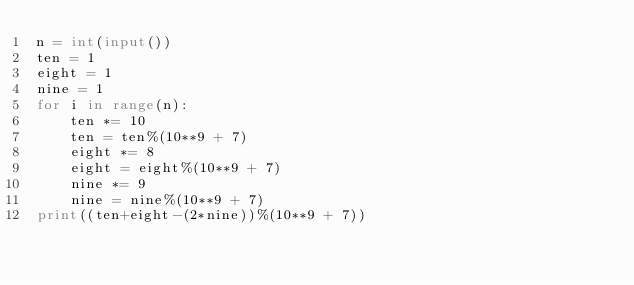Convert code to text. <code><loc_0><loc_0><loc_500><loc_500><_Python_>n = int(input())
ten = 1
eight = 1
nine = 1
for i in range(n):
    ten *= 10
    ten = ten%(10**9 + 7)
    eight *= 8
    eight = eight%(10**9 + 7)
    nine *= 9
    nine = nine%(10**9 + 7)
print((ten+eight-(2*nine))%(10**9 + 7))</code> 